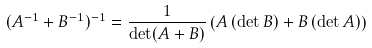Convert formula to latex. <formula><loc_0><loc_0><loc_500><loc_500>( A ^ { - 1 } + B ^ { - 1 } ) ^ { - 1 } = \frac { 1 } { \det ( A + B ) } \left ( A \, ( \det B ) + B \, ( \det A ) \right )</formula> 